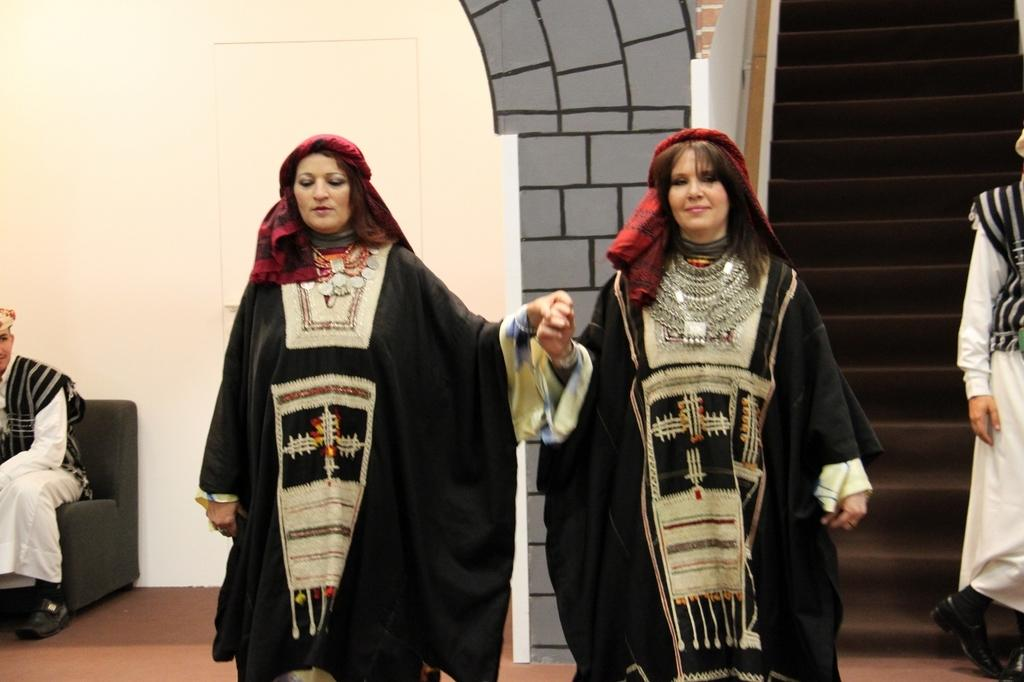How many people are in the image? There are people in the image, but the exact number is not specified. What is the position of one of the people in the image? One person is sitting on a chair. What are the other people in the image doing? Other people are standing. What can be seen in the background of the image? There is a wall and steps in the background of the image, as well as other unspecified objects. Is there a jail visible in the image? There is no mention of a jail in the image, so it cannot be confirmed or denied. 